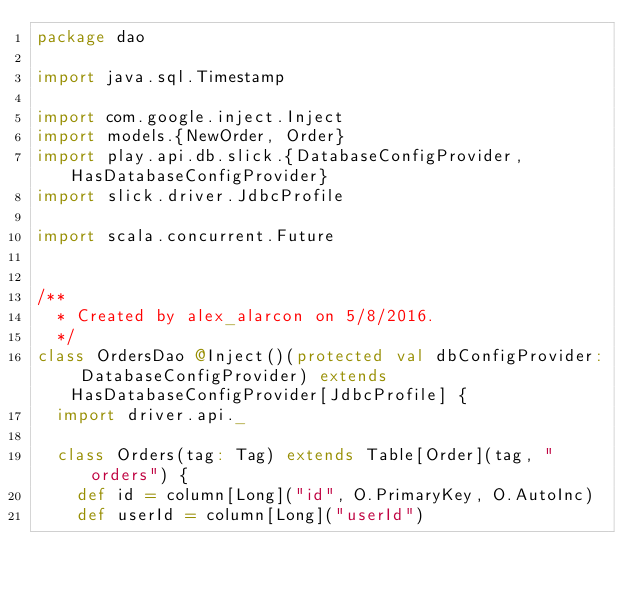<code> <loc_0><loc_0><loc_500><loc_500><_Scala_>package dao

import java.sql.Timestamp

import com.google.inject.Inject
import models.{NewOrder, Order}
import play.api.db.slick.{DatabaseConfigProvider, HasDatabaseConfigProvider}
import slick.driver.JdbcProfile

import scala.concurrent.Future


/**
  * Created by alex_alarcon on 5/8/2016.
  */
class OrdersDao @Inject()(protected val dbConfigProvider: DatabaseConfigProvider) extends HasDatabaseConfigProvider[JdbcProfile] {
  import driver.api._

  class Orders(tag: Tag) extends Table[Order](tag, "orders") {
    def id = column[Long]("id", O.PrimaryKey, O.AutoInc)
    def userId = column[Long]("userId")</code> 